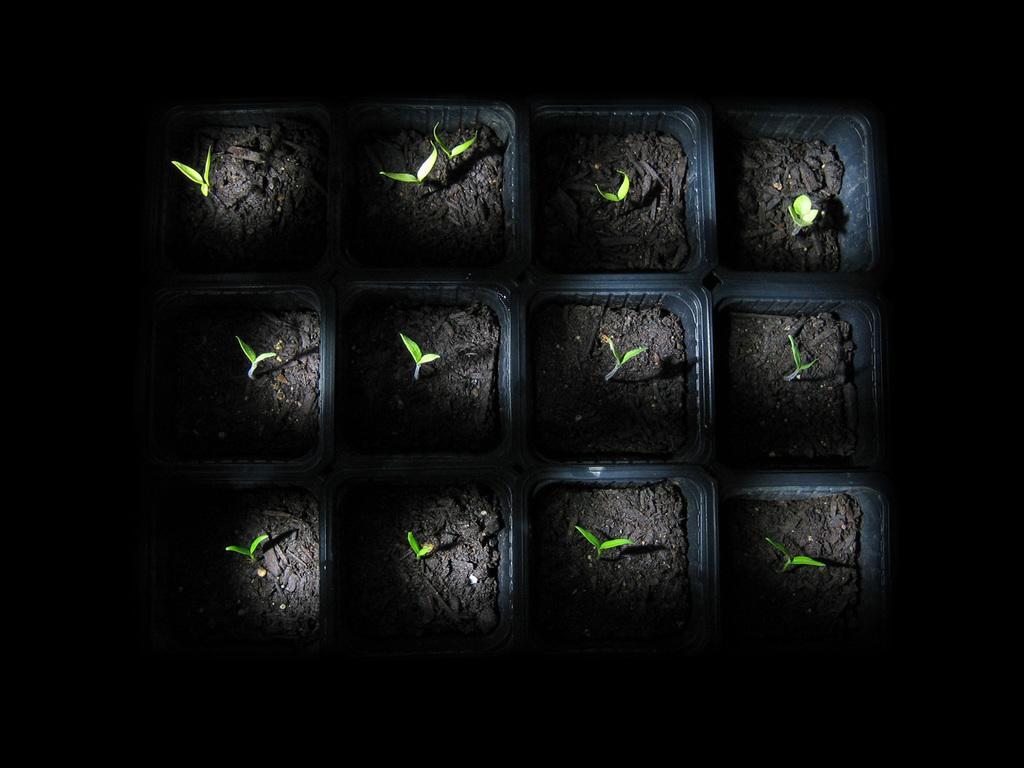How would you summarize this image in a sentence or two? In this image we can see a group of seedlings in the containers. 